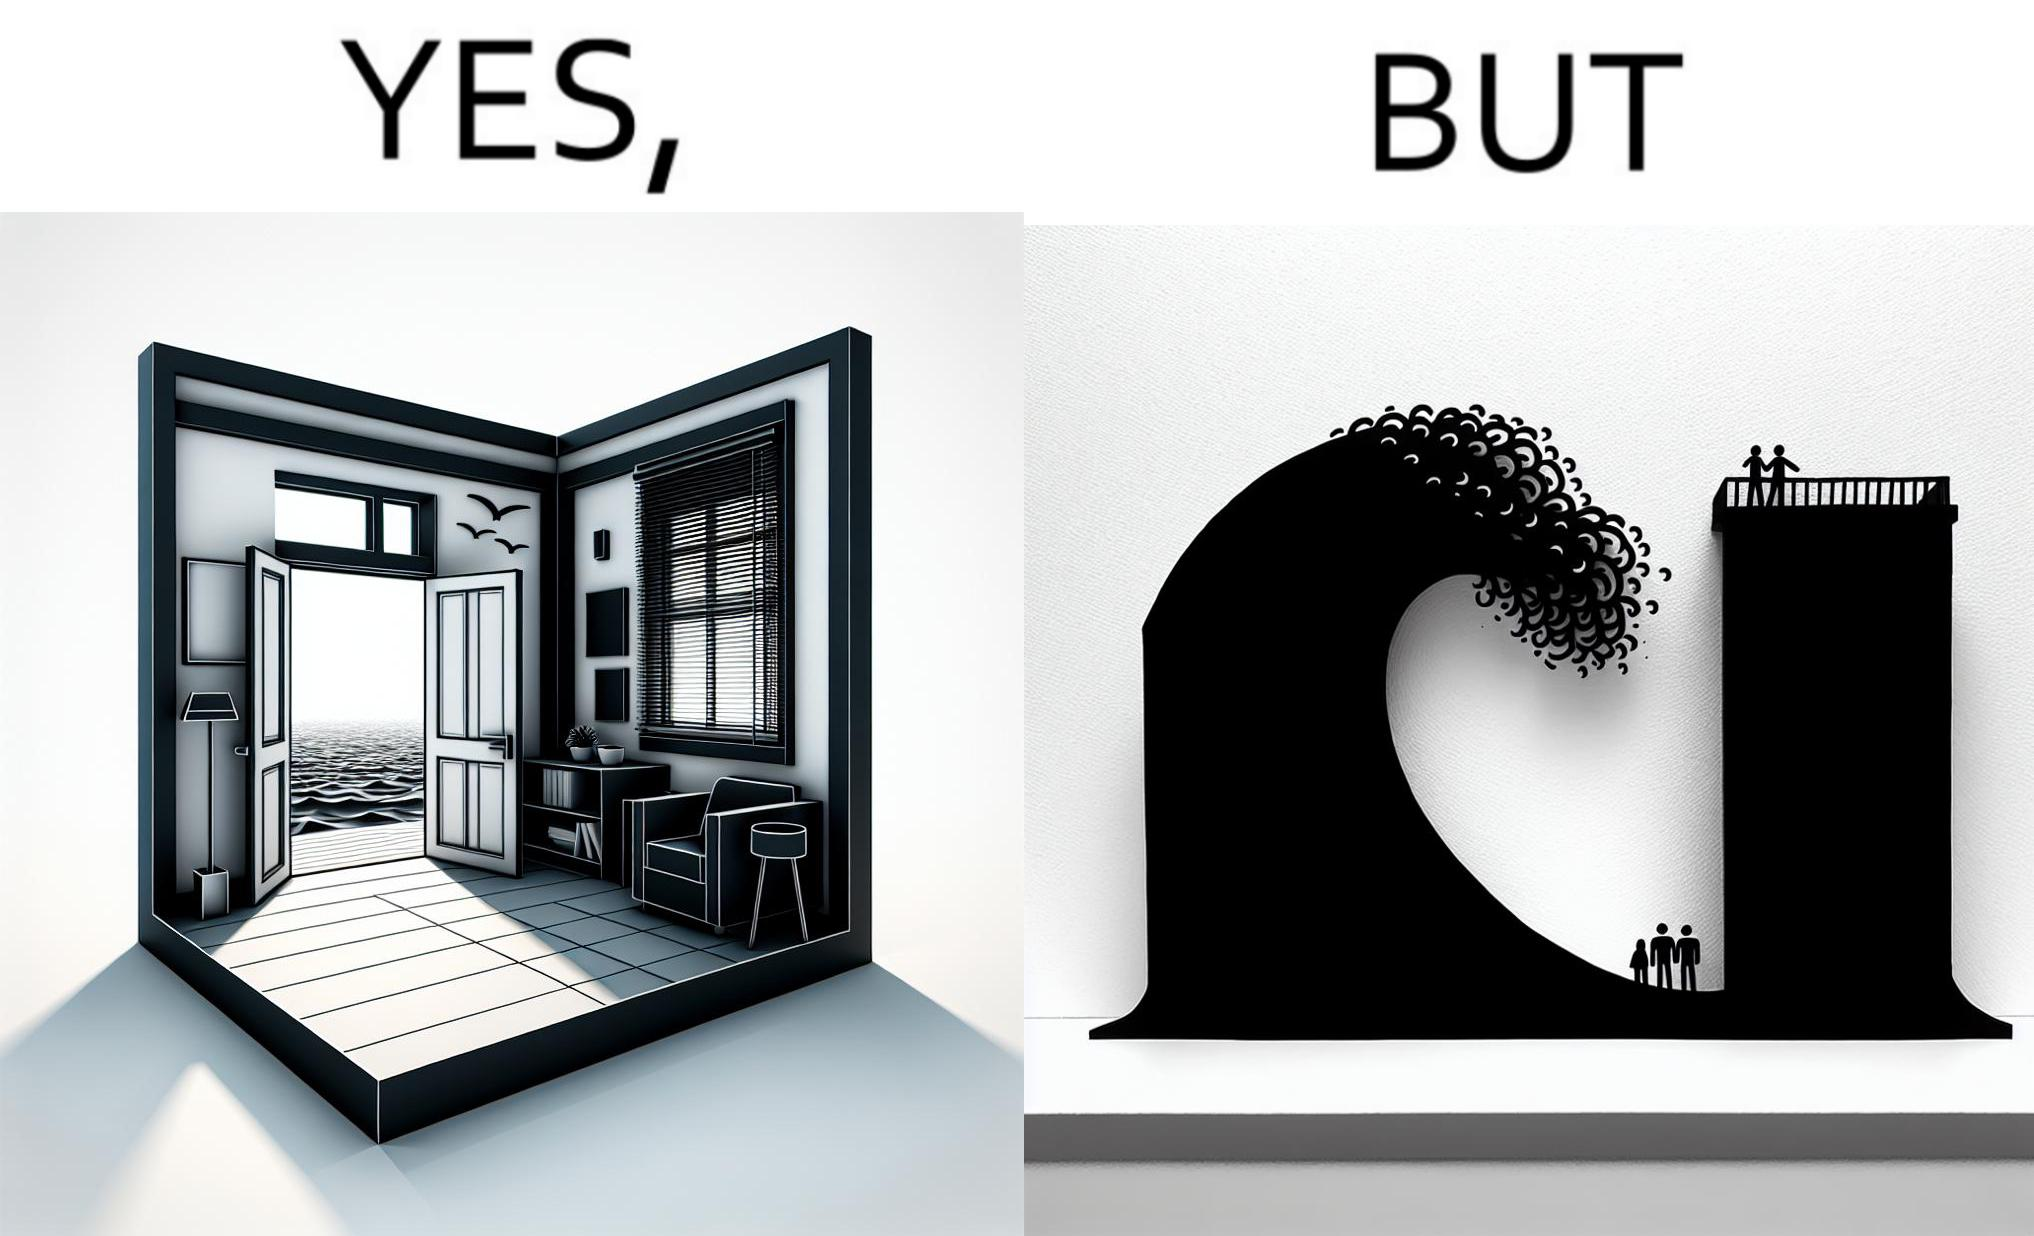Provide a description of this image. The same sea which gives us a relaxation on a normal day can pose a danger to us sometimes like during a tsunami 